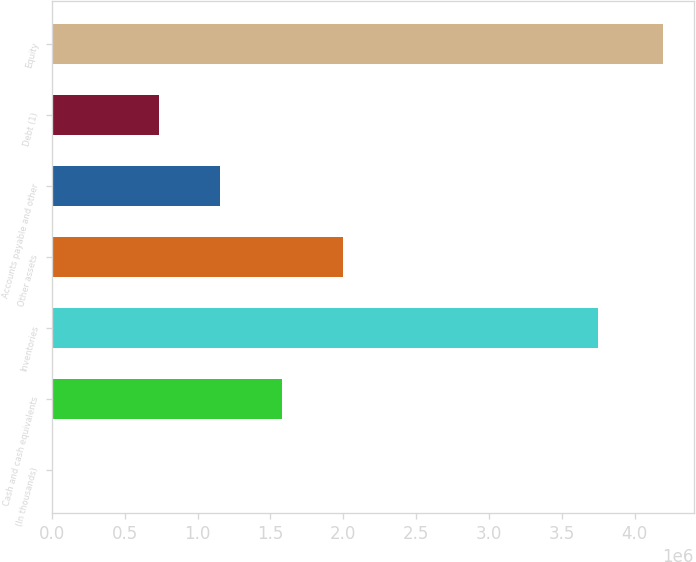Convert chart to OTSL. <chart><loc_0><loc_0><loc_500><loc_500><bar_chart><fcel>(In thousands)<fcel>Cash and cash equivalents<fcel>Inventories<fcel>Other assets<fcel>Accounts payable and other<fcel>Debt (1)<fcel>Equity<nl><fcel>2017<fcel>1.57629e+06<fcel>3.75152e+06<fcel>1.99577e+06<fcel>1.15681e+06<fcel>737331<fcel>4.19681e+06<nl></chart> 